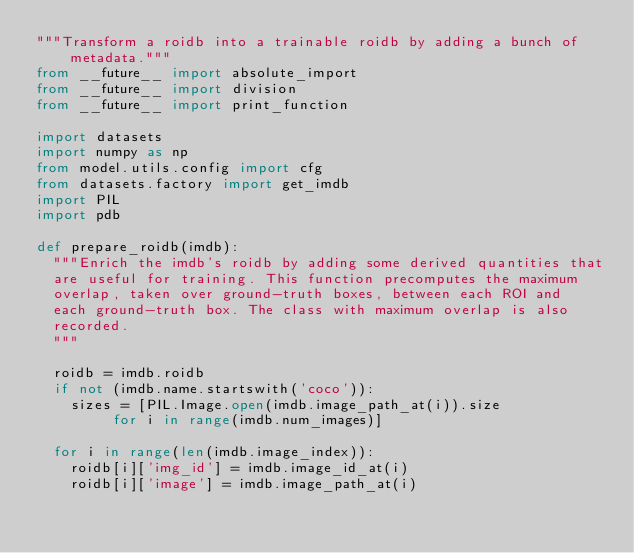Convert code to text. <code><loc_0><loc_0><loc_500><loc_500><_Python_>"""Transform a roidb into a trainable roidb by adding a bunch of metadata."""
from __future__ import absolute_import
from __future__ import division
from __future__ import print_function

import datasets
import numpy as np
from model.utils.config import cfg
from datasets.factory import get_imdb
import PIL
import pdb

def prepare_roidb(imdb):
  """Enrich the imdb's roidb by adding some derived quantities that
  are useful for training. This function precomputes the maximum
  overlap, taken over ground-truth boxes, between each ROI and
  each ground-truth box. The class with maximum overlap is also
  recorded.
  """

  roidb = imdb.roidb
  if not (imdb.name.startswith('coco')):
    sizes = [PIL.Image.open(imdb.image_path_at(i)).size
         for i in range(imdb.num_images)]
         
  for i in range(len(imdb.image_index)):
    roidb[i]['img_id'] = imdb.image_id_at(i)
    roidb[i]['image'] = imdb.image_path_at(i)</code> 